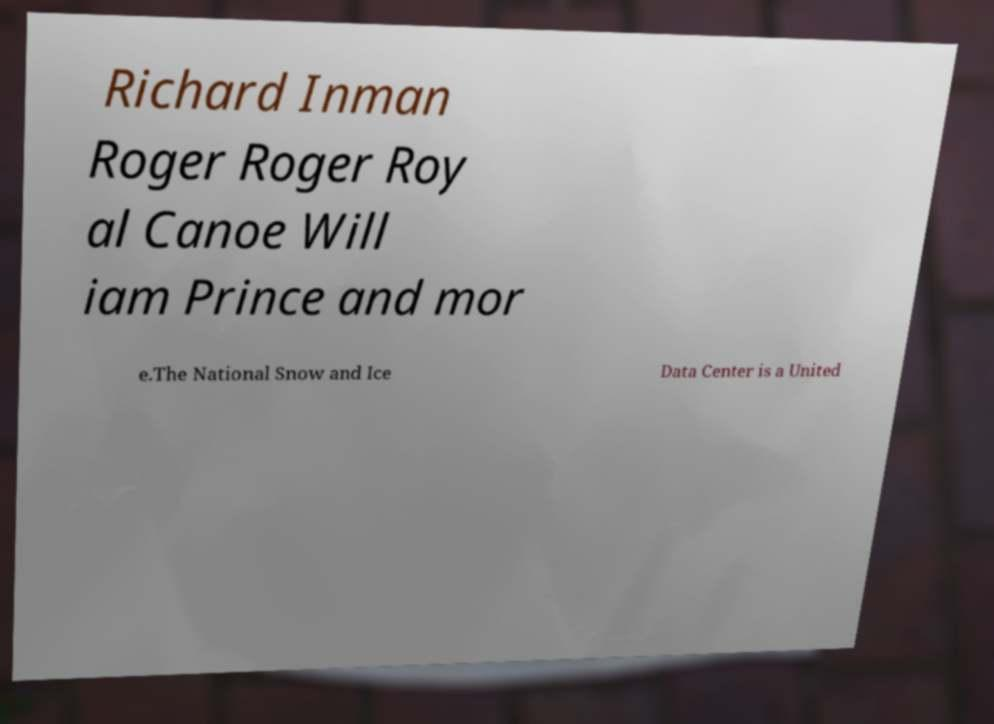Could you extract and type out the text from this image? Richard Inman Roger Roger Roy al Canoe Will iam Prince and mor e.The National Snow and Ice Data Center is a United 